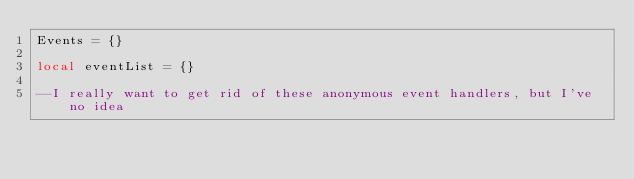<code> <loc_0><loc_0><loc_500><loc_500><_Lua_>Events = {}

local eventList = {}

--I really want to get rid of these anonymous event handlers, but I've no idea</code> 